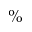Convert formula to latex. <formula><loc_0><loc_0><loc_500><loc_500>\%</formula> 